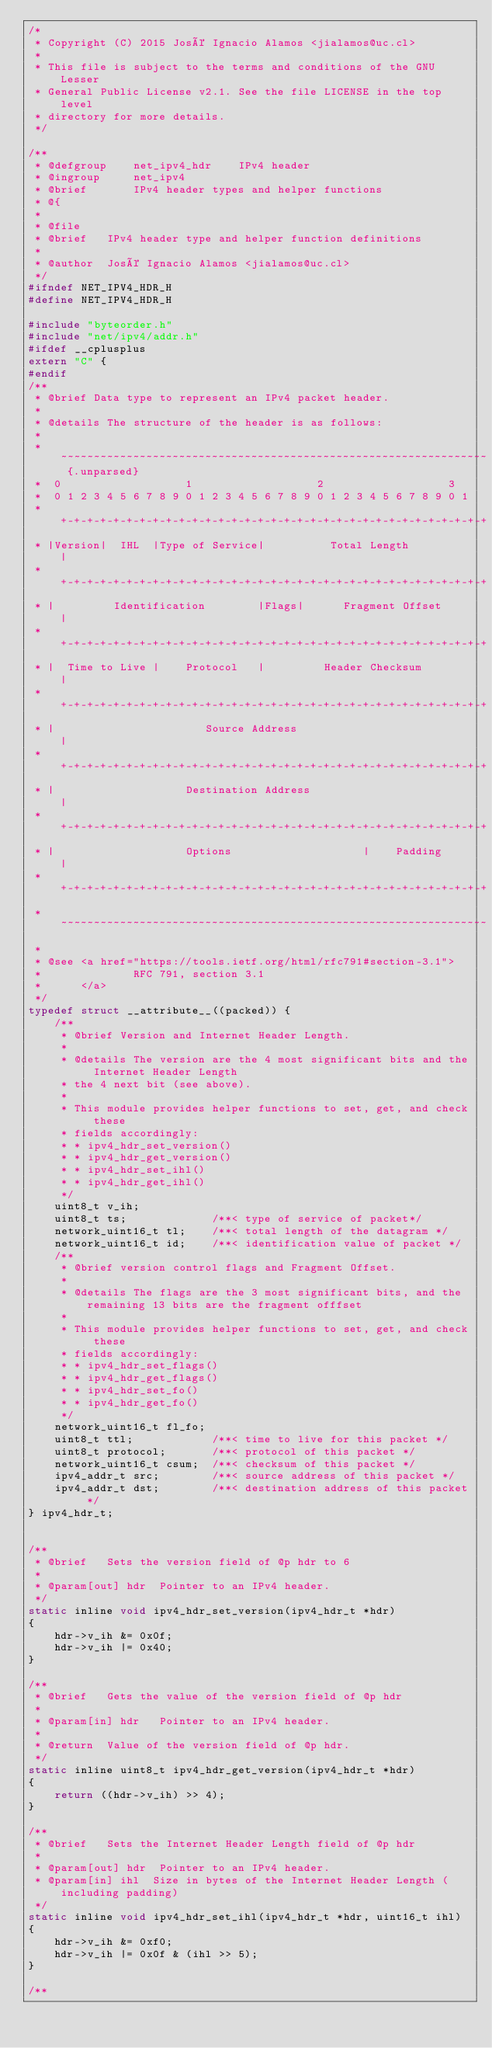Convert code to text. <code><loc_0><loc_0><loc_500><loc_500><_C_>/*
 * Copyright (C) 2015 José Ignacio Alamos <jialamos@uc.cl>
 *
 * This file is subject to the terms and conditions of the GNU Lesser
 * General Public License v2.1. See the file LICENSE in the top level
 * directory for more details.
 */

/**
 * @defgroup    net_ipv4_hdr    IPv4 header
 * @ingroup     net_ipv4
 * @brief       IPv4 header types and helper functions
 * @{
 *
 * @file
 * @brief   IPv4 header type and helper function definitions
 *
 * @author  José Ignacio Alamos <jialamos@uc.cl>
 */
#ifndef NET_IPV4_HDR_H
#define NET_IPV4_HDR_H

#include "byteorder.h"
#include "net/ipv4/addr.h"
#ifdef __cplusplus
extern "C" {
#endif
/**
 * @brief Data type to represent an IPv4 packet header.
 *
 * @details The structure of the header is as follows:
 *
 * ~~~~~~~~~~~~~~~~~~~~~~~~~~~~~~~~~~~~~~~~~~~~~~~~~~~~~~~~~~~~~~~~~ {.unparsed}
 *  0                   1                   2                   3
 *  0 1 2 3 4 5 6 7 8 9 0 1 2 3 4 5 6 7 8 9 0 1 2 3 4 5 6 7 8 9 0 1
 * +-+-+-+-+-+-+-+-+-+-+-+-+-+-+-+-+-+-+-+-+-+-+-+-+-+-+-+-+-+-+-+-+
 * |Version|  IHL  |Type of Service|          Total Length         |
 * +-+-+-+-+-+-+-+-+-+-+-+-+-+-+-+-+-+-+-+-+-+-+-+-+-+-+-+-+-+-+-+-+
 * |         Identification        |Flags|      Fragment Offset    |
 * +-+-+-+-+-+-+-+-+-+-+-+-+-+-+-+-+-+-+-+-+-+-+-+-+-+-+-+-+-+-+-+-+
 * |  Time to Live |    Protocol   |         Header Checksum       |
 * +-+-+-+-+-+-+-+-+-+-+-+-+-+-+-+-+-+-+-+-+-+-+-+-+-+-+-+-+-+-+-+-+
 * |                       Source Address                          |
 * +-+-+-+-+-+-+-+-+-+-+-+-+-+-+-+-+-+-+-+-+-+-+-+-+-+-+-+-+-+-+-+-+
 * |                    Destination Address                        |
 * +-+-+-+-+-+-+-+-+-+-+-+-+-+-+-+-+-+-+-+-+-+-+-+-+-+-+-+-+-+-+-+-+
 * |                    Options                    |    Padding    |
 * +-+-+-+-+-+-+-+-+-+-+-+-+-+-+-+-+-+-+-+-+-+-+-+-+-+-+-+-+-+-+-+-+
 * ~~~~~~~~~~~~~~~~~~~~~~~~~~~~~~~~~~~~~~~~~~~~~~~~~~~~~~~~~~~~~~~~~
 *
 * @see <a href="https://tools.ietf.org/html/rfc791#section-3.1">
 *              RFC 791, section 3.1
 *      </a>
 */
typedef struct __attribute__((packed)) {
    /**
     * @brief Version and Internet Header Length.
     *
     * @details The version are the 4 most significant bits and the Internet Header Length
     * the 4 next bit (see above).
     *
     * This module provides helper functions to set, get, and check these
     * fields accordingly:
     * * ipv4_hdr_set_version()
     * * ipv4_hdr_get_version()
     * * ipv4_hdr_set_ihl()
     * * ipv4_hdr_get_ihl()
     */
    uint8_t v_ih;
    uint8_t ts;             /**< type of service of packet*/
    network_uint16_t tl;    /**< total length of the datagram */
    network_uint16_t id;    /**< identification value of packet */
    /**
     * @brief version control flags and Fragment Offset.
     *
     * @details The flags are the 3 most significant bits, and the remaining 13 bits are the fragment offfset
     *
     * This module provides helper functions to set, get, and check these
     * fields accordingly:
     * * ipv4_hdr_set_flags()
     * * ipv4_hdr_get_flags()
     * * ipv4_hdr_set_fo()
     * * ipv4_hdr_get_fo()
     */
    network_uint16_t fl_fo;
    uint8_t ttl;            /**< time to live for this packet */
    uint8_t protocol;       /**< protocol of this packet */
    network_uint16_t csum;  /**< checksum of this packet */
    ipv4_addr_t src;        /**< source address of this packet */
    ipv4_addr_t dst;        /**< destination address of this packet */
} ipv4_hdr_t;


/**
 * @brief   Sets the version field of @p hdr to 6
 *
 * @param[out] hdr  Pointer to an IPv4 header.
 */
static inline void ipv4_hdr_set_version(ipv4_hdr_t *hdr)
{
    hdr->v_ih &= 0x0f;
    hdr->v_ih |= 0x40;
}

/**
 * @brief   Gets the value of the version field of @p hdr
 *
 * @param[in] hdr   Pointer to an IPv4 header.
 *
 * @return  Value of the version field of @p hdr.
 */
static inline uint8_t ipv4_hdr_get_version(ipv4_hdr_t *hdr)
{
    return ((hdr->v_ih) >> 4);
}

/**
 * @brief   Sets the Internet Header Length field of @p hdr
 *
 * @param[out] hdr  Pointer to an IPv4 header.
 * @param[in] ihl  Size in bytes of the Internet Header Length (including padding)
 */
static inline void ipv4_hdr_set_ihl(ipv4_hdr_t *hdr, uint16_t ihl)
{
    hdr->v_ih &= 0xf0;
    hdr->v_ih |= 0x0f & (ihl >> 5);
}

/**</code> 